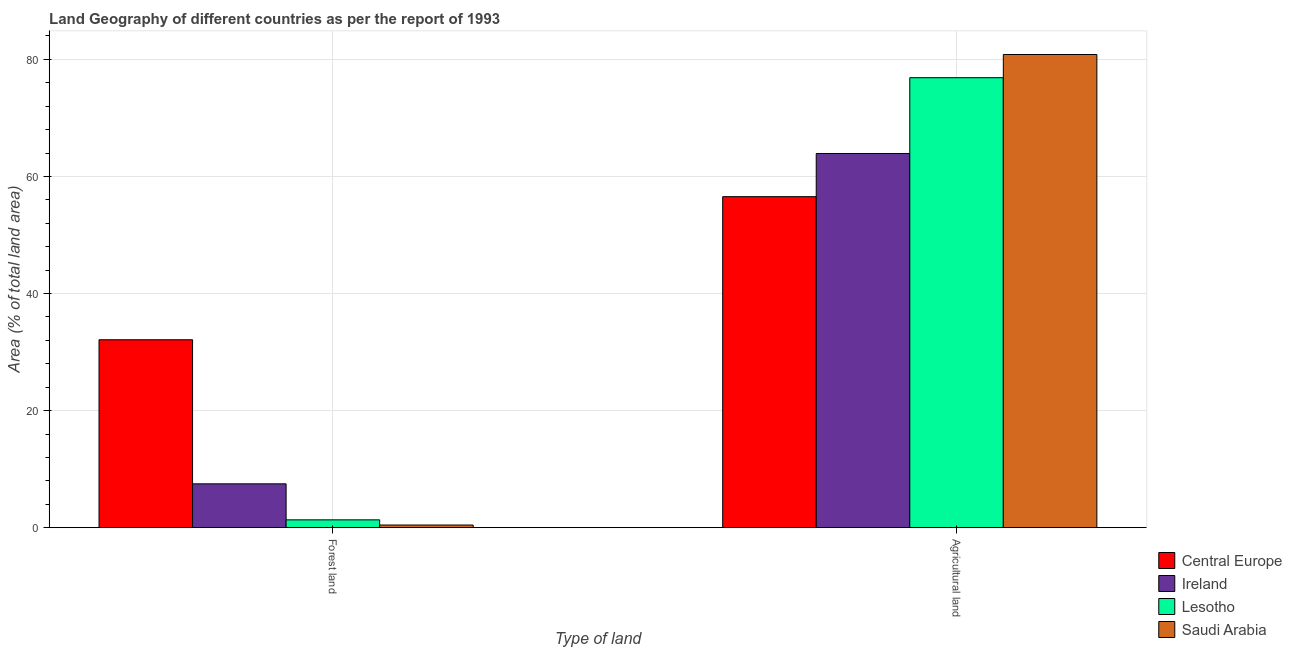How many groups of bars are there?
Give a very brief answer. 2. Are the number of bars on each tick of the X-axis equal?
Your answer should be compact. Yes. How many bars are there on the 2nd tick from the left?
Offer a terse response. 4. What is the label of the 2nd group of bars from the left?
Ensure brevity in your answer.  Agricultural land. What is the percentage of land area under agriculture in Saudi Arabia?
Keep it short and to the point. 80.84. Across all countries, what is the maximum percentage of land area under agriculture?
Make the answer very short. 80.84. Across all countries, what is the minimum percentage of land area under agriculture?
Make the answer very short. 56.55. In which country was the percentage of land area under forests maximum?
Your answer should be compact. Central Europe. In which country was the percentage of land area under agriculture minimum?
Offer a terse response. Central Europe. What is the total percentage of land area under forests in the graph?
Your answer should be compact. 41.39. What is the difference between the percentage of land area under agriculture in Saudi Arabia and that in Ireland?
Keep it short and to the point. 16.91. What is the difference between the percentage of land area under agriculture in Saudi Arabia and the percentage of land area under forests in Central Europe?
Offer a terse response. 48.74. What is the average percentage of land area under agriculture per country?
Your answer should be compact. 69.55. What is the difference between the percentage of land area under agriculture and percentage of land area under forests in Saudi Arabia?
Your response must be concise. 80.39. In how many countries, is the percentage of land area under forests greater than 64 %?
Your response must be concise. 0. What is the ratio of the percentage of land area under forests in Central Europe to that in Ireland?
Give a very brief answer. 4.29. In how many countries, is the percentage of land area under agriculture greater than the average percentage of land area under agriculture taken over all countries?
Make the answer very short. 2. What does the 3rd bar from the left in Agricultural land represents?
Your response must be concise. Lesotho. What does the 1st bar from the right in Forest land represents?
Provide a succinct answer. Saudi Arabia. How many countries are there in the graph?
Offer a terse response. 4. Does the graph contain any zero values?
Offer a very short reply. No. Does the graph contain grids?
Keep it short and to the point. Yes. What is the title of the graph?
Give a very brief answer. Land Geography of different countries as per the report of 1993. Does "Nicaragua" appear as one of the legend labels in the graph?
Your answer should be compact. No. What is the label or title of the X-axis?
Your answer should be very brief. Type of land. What is the label or title of the Y-axis?
Provide a succinct answer. Area (% of total land area). What is the Area (% of total land area) of Central Europe in Forest land?
Provide a succinct answer. 32.11. What is the Area (% of total land area) of Ireland in Forest land?
Make the answer very short. 7.49. What is the Area (% of total land area) in Lesotho in Forest land?
Ensure brevity in your answer.  1.34. What is the Area (% of total land area) in Saudi Arabia in Forest land?
Provide a succinct answer. 0.45. What is the Area (% of total land area) of Central Europe in Agricultural land?
Keep it short and to the point. 56.55. What is the Area (% of total land area) in Ireland in Agricultural land?
Your answer should be compact. 63.93. What is the Area (% of total land area) of Lesotho in Agricultural land?
Your response must be concise. 76.88. What is the Area (% of total land area) in Saudi Arabia in Agricultural land?
Provide a succinct answer. 80.84. Across all Type of land, what is the maximum Area (% of total land area) of Central Europe?
Make the answer very short. 56.55. Across all Type of land, what is the maximum Area (% of total land area) of Ireland?
Keep it short and to the point. 63.93. Across all Type of land, what is the maximum Area (% of total land area) of Lesotho?
Your response must be concise. 76.88. Across all Type of land, what is the maximum Area (% of total land area) of Saudi Arabia?
Make the answer very short. 80.84. Across all Type of land, what is the minimum Area (% of total land area) in Central Europe?
Ensure brevity in your answer.  32.11. Across all Type of land, what is the minimum Area (% of total land area) of Ireland?
Ensure brevity in your answer.  7.49. Across all Type of land, what is the minimum Area (% of total land area) of Lesotho?
Offer a terse response. 1.34. Across all Type of land, what is the minimum Area (% of total land area) in Saudi Arabia?
Make the answer very short. 0.45. What is the total Area (% of total land area) of Central Europe in the graph?
Keep it short and to the point. 88.66. What is the total Area (% of total land area) of Ireland in the graph?
Offer a very short reply. 71.42. What is the total Area (% of total land area) in Lesotho in the graph?
Ensure brevity in your answer.  78.21. What is the total Area (% of total land area) in Saudi Arabia in the graph?
Your response must be concise. 81.3. What is the difference between the Area (% of total land area) of Central Europe in Forest land and that in Agricultural land?
Offer a very short reply. -24.45. What is the difference between the Area (% of total land area) in Ireland in Forest land and that in Agricultural land?
Your answer should be very brief. -56.44. What is the difference between the Area (% of total land area) in Lesotho in Forest land and that in Agricultural land?
Keep it short and to the point. -75.54. What is the difference between the Area (% of total land area) in Saudi Arabia in Forest land and that in Agricultural land?
Your answer should be very brief. -80.39. What is the difference between the Area (% of total land area) in Central Europe in Forest land and the Area (% of total land area) in Ireland in Agricultural land?
Offer a terse response. -31.82. What is the difference between the Area (% of total land area) of Central Europe in Forest land and the Area (% of total land area) of Lesotho in Agricultural land?
Keep it short and to the point. -44.77. What is the difference between the Area (% of total land area) of Central Europe in Forest land and the Area (% of total land area) of Saudi Arabia in Agricultural land?
Ensure brevity in your answer.  -48.74. What is the difference between the Area (% of total land area) of Ireland in Forest land and the Area (% of total land area) of Lesotho in Agricultural land?
Give a very brief answer. -69.39. What is the difference between the Area (% of total land area) in Ireland in Forest land and the Area (% of total land area) in Saudi Arabia in Agricultural land?
Your response must be concise. -73.35. What is the difference between the Area (% of total land area) of Lesotho in Forest land and the Area (% of total land area) of Saudi Arabia in Agricultural land?
Offer a very short reply. -79.5. What is the average Area (% of total land area) of Central Europe per Type of land?
Ensure brevity in your answer.  44.33. What is the average Area (% of total land area) of Ireland per Type of land?
Offer a terse response. 35.71. What is the average Area (% of total land area) in Lesotho per Type of land?
Make the answer very short. 39.11. What is the average Area (% of total land area) of Saudi Arabia per Type of land?
Offer a very short reply. 40.65. What is the difference between the Area (% of total land area) in Central Europe and Area (% of total land area) in Ireland in Forest land?
Provide a short and direct response. 24.62. What is the difference between the Area (% of total land area) of Central Europe and Area (% of total land area) of Lesotho in Forest land?
Your response must be concise. 30.77. What is the difference between the Area (% of total land area) in Central Europe and Area (% of total land area) in Saudi Arabia in Forest land?
Offer a very short reply. 31.65. What is the difference between the Area (% of total land area) of Ireland and Area (% of total land area) of Lesotho in Forest land?
Provide a short and direct response. 6.15. What is the difference between the Area (% of total land area) of Ireland and Area (% of total land area) of Saudi Arabia in Forest land?
Offer a terse response. 7.04. What is the difference between the Area (% of total land area) in Lesotho and Area (% of total land area) in Saudi Arabia in Forest land?
Provide a short and direct response. 0.88. What is the difference between the Area (% of total land area) of Central Europe and Area (% of total land area) of Ireland in Agricultural land?
Provide a succinct answer. -7.38. What is the difference between the Area (% of total land area) of Central Europe and Area (% of total land area) of Lesotho in Agricultural land?
Your answer should be compact. -20.33. What is the difference between the Area (% of total land area) in Central Europe and Area (% of total land area) in Saudi Arabia in Agricultural land?
Keep it short and to the point. -24.29. What is the difference between the Area (% of total land area) in Ireland and Area (% of total land area) in Lesotho in Agricultural land?
Your response must be concise. -12.95. What is the difference between the Area (% of total land area) of Ireland and Area (% of total land area) of Saudi Arabia in Agricultural land?
Your response must be concise. -16.91. What is the difference between the Area (% of total land area) in Lesotho and Area (% of total land area) in Saudi Arabia in Agricultural land?
Provide a short and direct response. -3.96. What is the ratio of the Area (% of total land area) in Central Europe in Forest land to that in Agricultural land?
Provide a short and direct response. 0.57. What is the ratio of the Area (% of total land area) of Ireland in Forest land to that in Agricultural land?
Provide a succinct answer. 0.12. What is the ratio of the Area (% of total land area) in Lesotho in Forest land to that in Agricultural land?
Provide a short and direct response. 0.02. What is the ratio of the Area (% of total land area) in Saudi Arabia in Forest land to that in Agricultural land?
Your answer should be compact. 0.01. What is the difference between the highest and the second highest Area (% of total land area) of Central Europe?
Keep it short and to the point. 24.45. What is the difference between the highest and the second highest Area (% of total land area) of Ireland?
Your response must be concise. 56.44. What is the difference between the highest and the second highest Area (% of total land area) of Lesotho?
Keep it short and to the point. 75.54. What is the difference between the highest and the second highest Area (% of total land area) of Saudi Arabia?
Give a very brief answer. 80.39. What is the difference between the highest and the lowest Area (% of total land area) in Central Europe?
Make the answer very short. 24.45. What is the difference between the highest and the lowest Area (% of total land area) in Ireland?
Ensure brevity in your answer.  56.44. What is the difference between the highest and the lowest Area (% of total land area) in Lesotho?
Provide a succinct answer. 75.54. What is the difference between the highest and the lowest Area (% of total land area) in Saudi Arabia?
Your response must be concise. 80.39. 